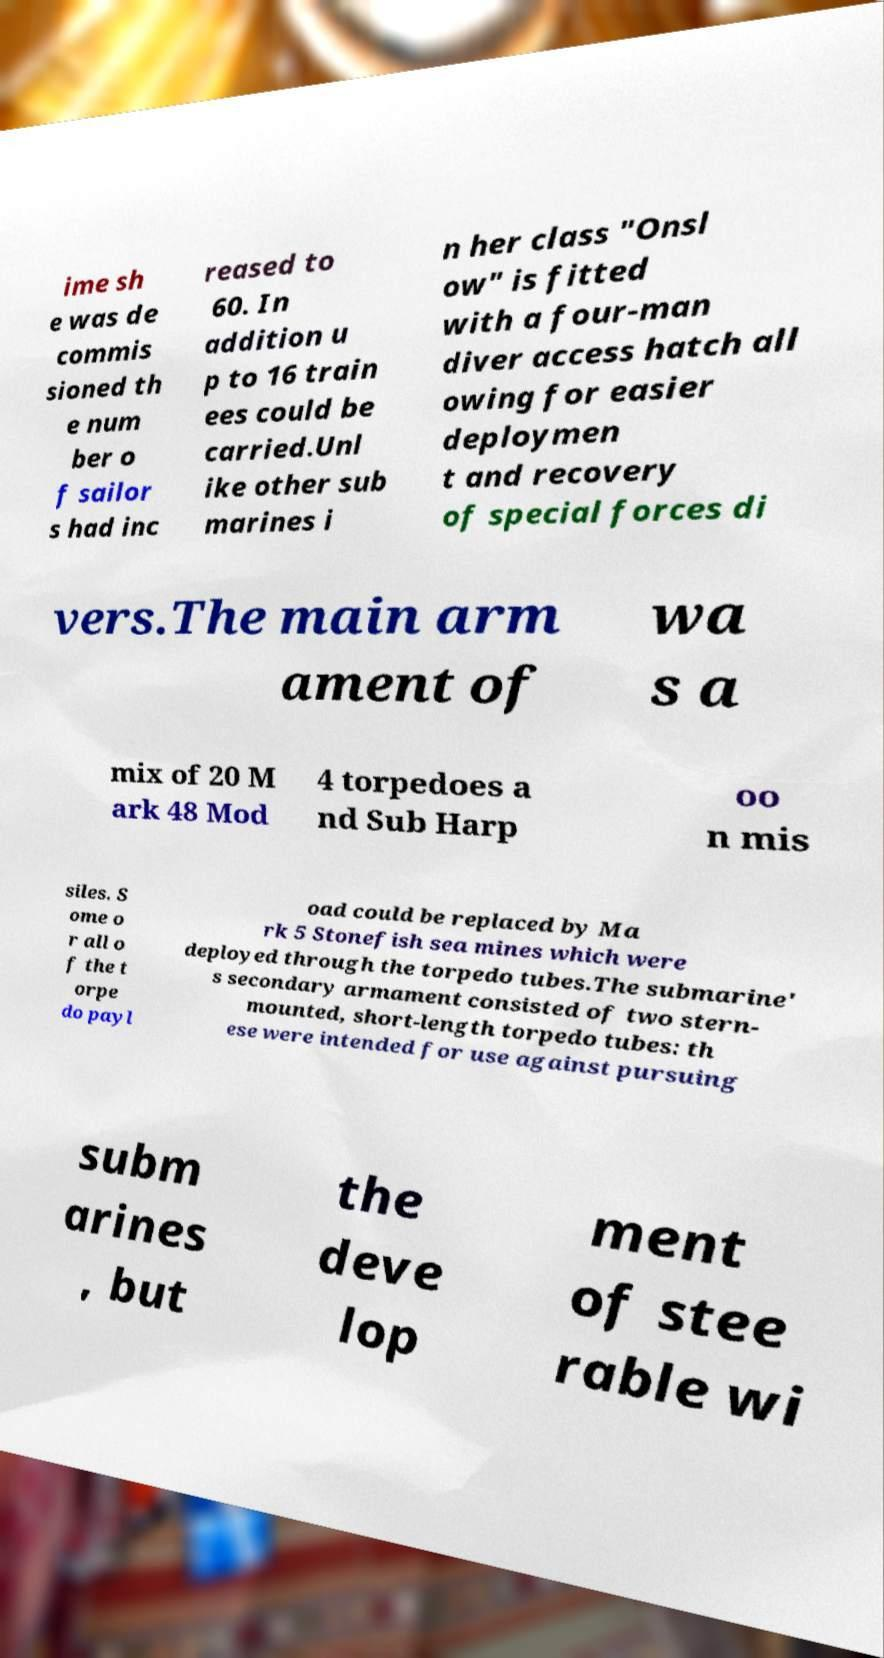Please read and relay the text visible in this image. What does it say? ime sh e was de commis sioned th e num ber o f sailor s had inc reased to 60. In addition u p to 16 train ees could be carried.Unl ike other sub marines i n her class "Onsl ow" is fitted with a four-man diver access hatch all owing for easier deploymen t and recovery of special forces di vers.The main arm ament of wa s a mix of 20 M ark 48 Mod 4 torpedoes a nd Sub Harp oo n mis siles. S ome o r all o f the t orpe do payl oad could be replaced by Ma rk 5 Stonefish sea mines which were deployed through the torpedo tubes.The submarine' s secondary armament consisted of two stern- mounted, short-length torpedo tubes: th ese were intended for use against pursuing subm arines , but the deve lop ment of stee rable wi 